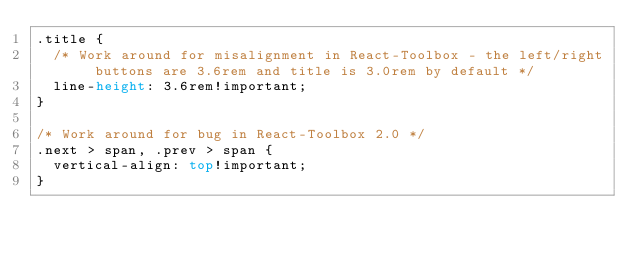Convert code to text. <code><loc_0><loc_0><loc_500><loc_500><_CSS_>.title {
  /* Work around for misalignment in React-Toolbox - the left/right buttons are 3.6rem and title is 3.0rem by default */
  line-height: 3.6rem!important;
}

/* Work around for bug in React-Toolbox 2.0 */
.next > span, .prev > span {
  vertical-align: top!important;
}</code> 